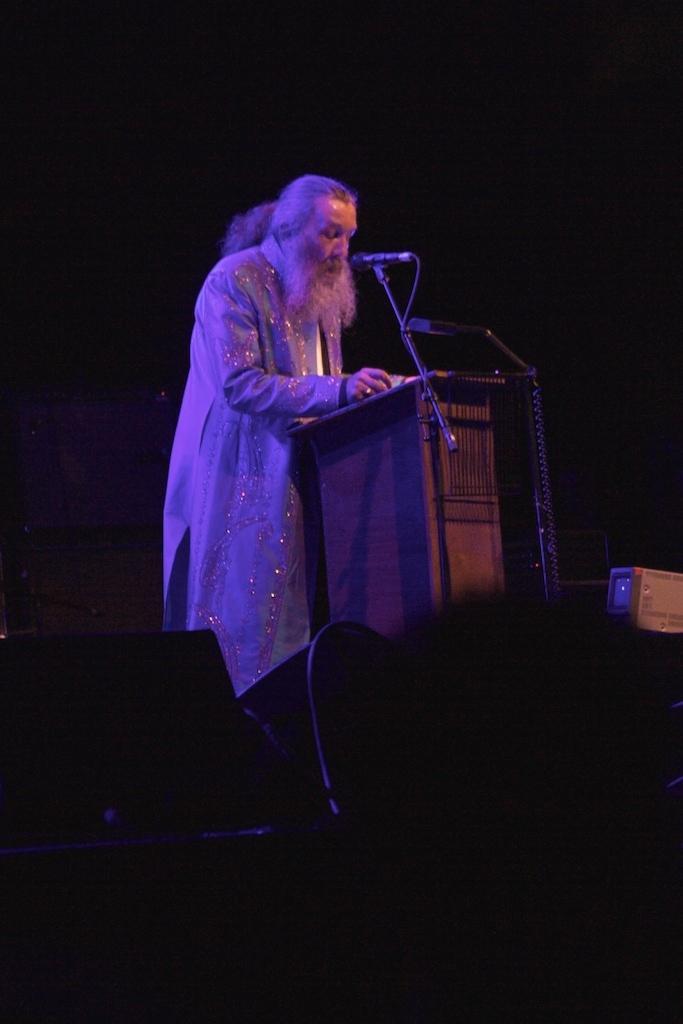Could you give a brief overview of what you see in this image? In this image an old man is standing beside a podium. On the podium there is a mic. These are the speakers. The background is dark. 